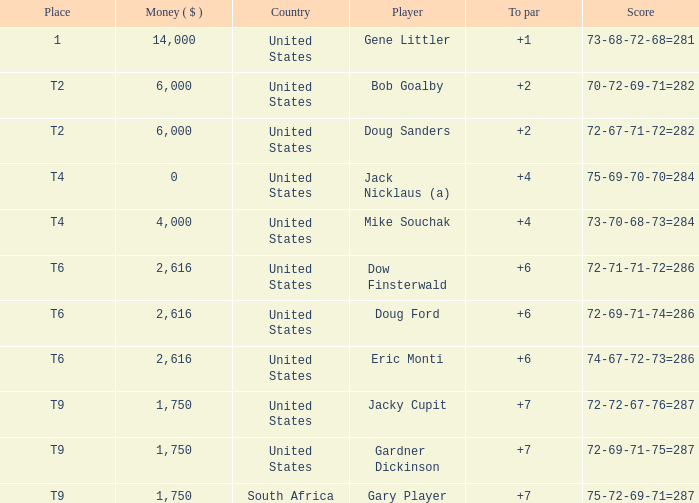What is the average To Par, when Score is "72-67-71-72=282"? 2.0. 